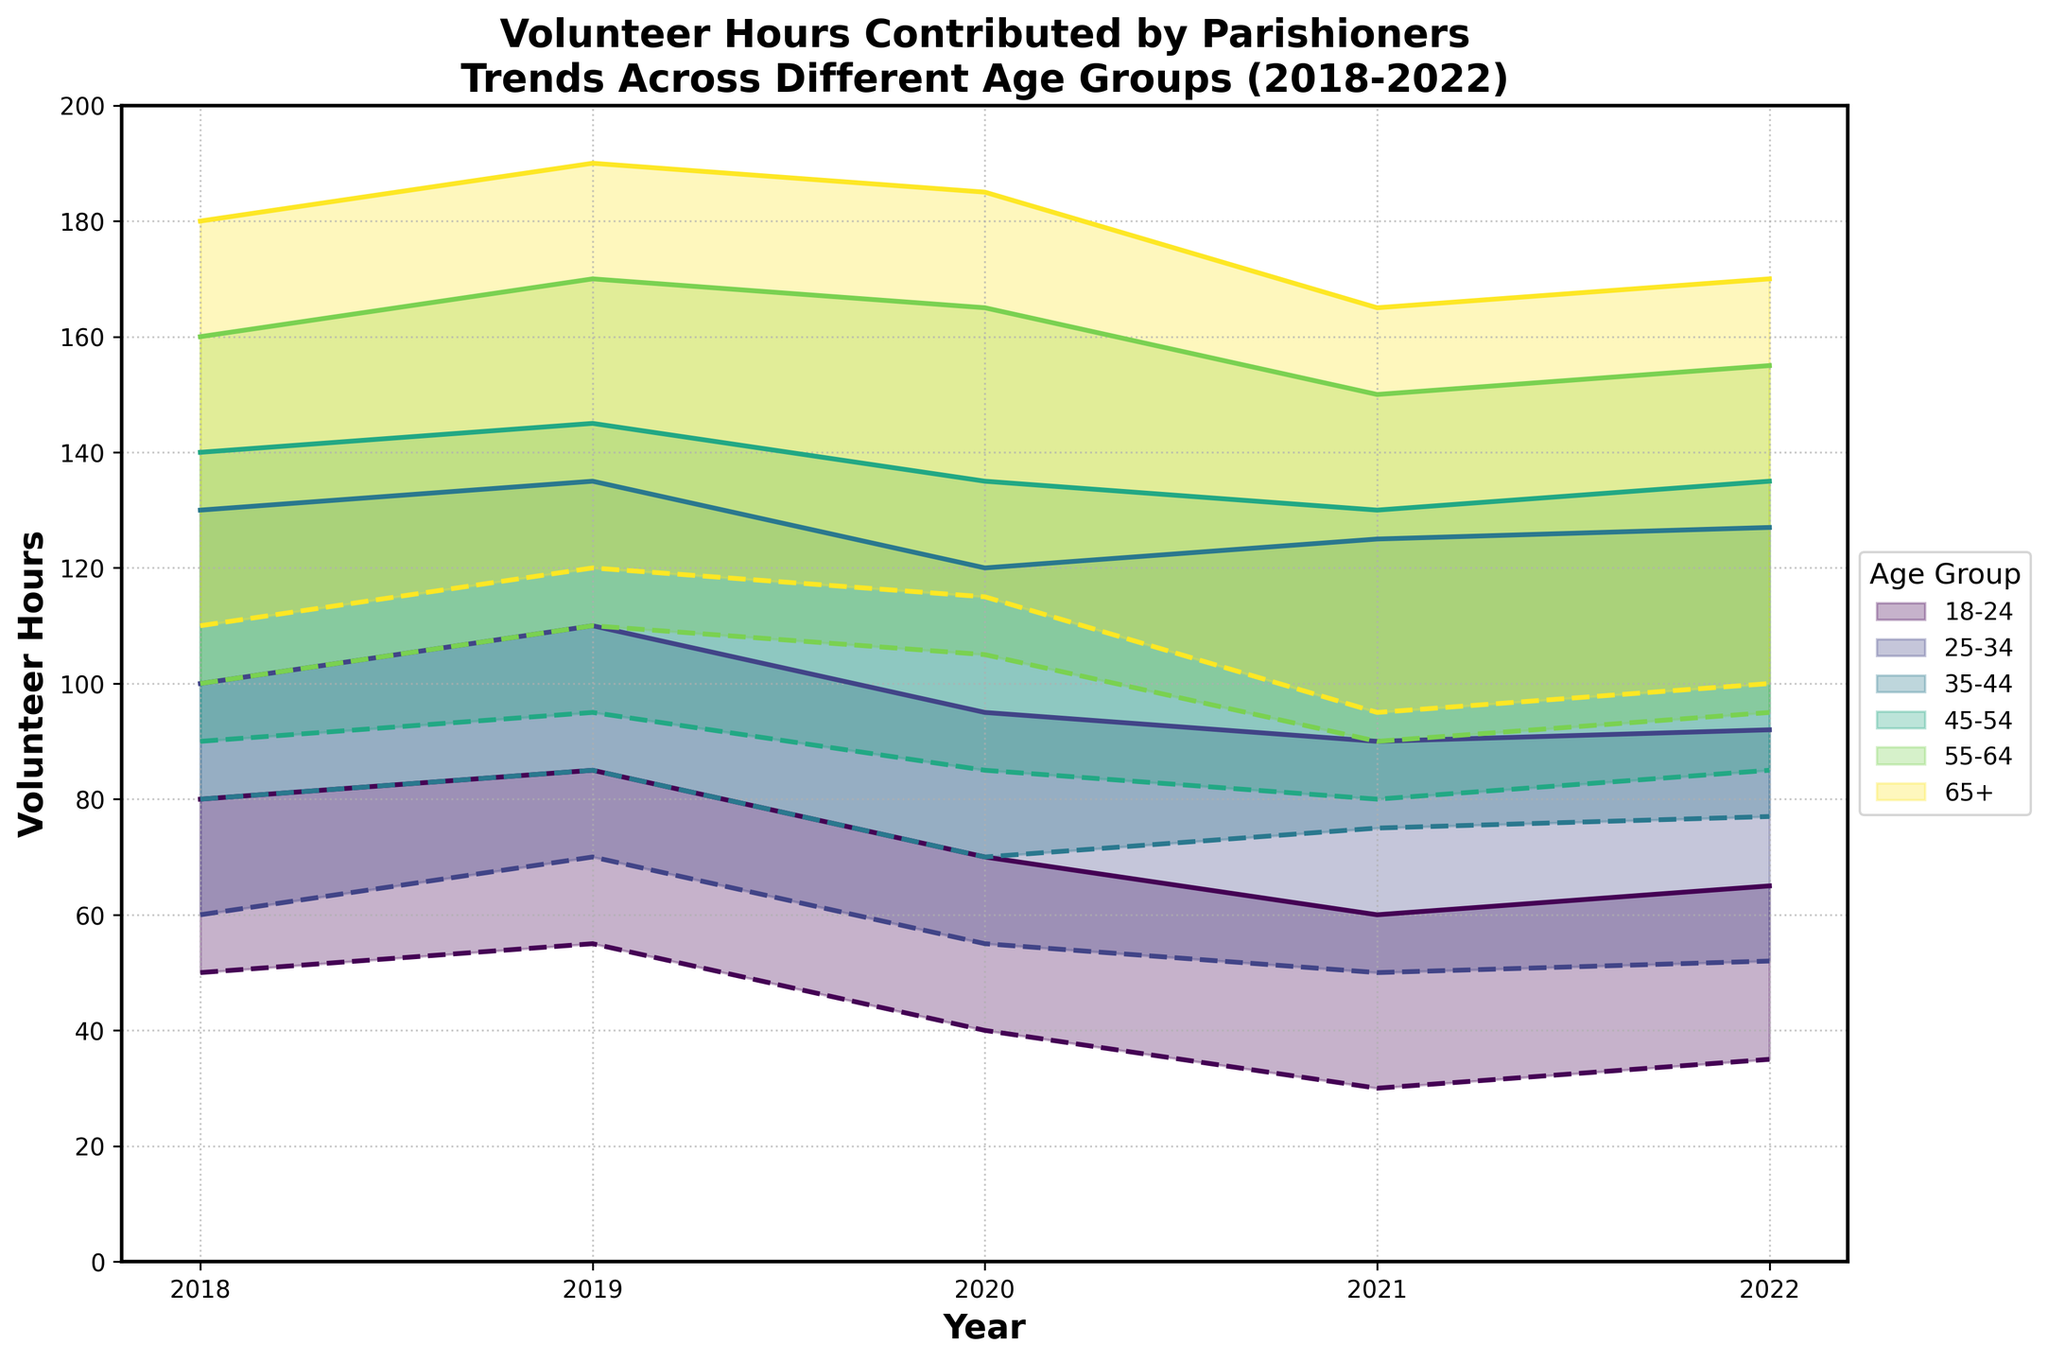How have volunteer hours for the 18-24 age group changed from 2018 to 2022? To find the change, observe the range of volunteer hours for the 18-24 age group over the years. The min hours in 2018 were 50, and in 2022 they are 35. The max hours in 2018 were 80, and in 2022 they are 65. Both min and max values have decreased.
Answer: Decreased Which age group had the highest volunteer hours consistently from 2018 to 2022? Review the figure and compare the max hours across all age groups for each year between 2018 and 2022. The 65+ age group had the highest max hours for every year.
Answer: 65+ What is the minimum volunteer hours range for the 35-44 age group over the years? Identify the min hours for the 35-44 age group from 2018 to 2022. The values range from 70 in 2020 to 85 in 2019.
Answer: 70 to 85 Which year showed the highest max volunteer hours for the 55-64 age group? Check the max hours data for the 55-64 age group each year. The highest max hours were in 2019 with 170 hours.
Answer: 2019 How did the volunteer hours for the 25-34 age group change from 2020 to 2021? Find the min and max hours for the 25-34 age group in 2020 (55, 95) and in 2021 (50, 90). There was a decrease in both min and max hours.
Answer: Decreased Compare the trend of min volunteer hours between the 45-54 and 55-64 age groups from 2018 to 2022. The 45-54 age group starts at 90 in 2018 and ends at 85 in 2022. The 55-64 age group starts at 100 in 2018 and ends at 95 in 2022. Both groups show an overall decrease, but the 45-54 group had a smaller reduction (5 hours) compared to the 55-64 group (5 hours).
Answer: Both decreased; 45-54 decreased by 5 hours, 55-64 decreased by 5 hours Which age group showed the most significant decrease in max volunteer hours during the five-year period? Compare the max hours for all age groups in 2018 and 2022. The 65+ age group decreased from 180 in 2018 to 170 in 2022, a reduction of 10 hours, which is the most significant decrease.
Answer: 65+, 10 hours What was the max volunteer hours range for the 18-24 age group from 2018 to 2022? Identify the max hours for the 18-24 age group each year. The range varies from 60 to 85.
Answer: 60 to 85 